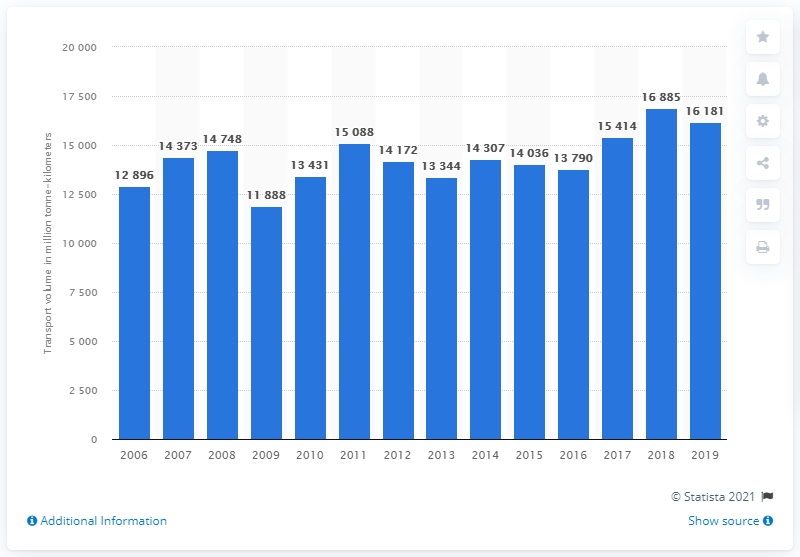Specify some key components in this picture. In 2019, the rail freight transport volume in Lithuania was 16,181. 